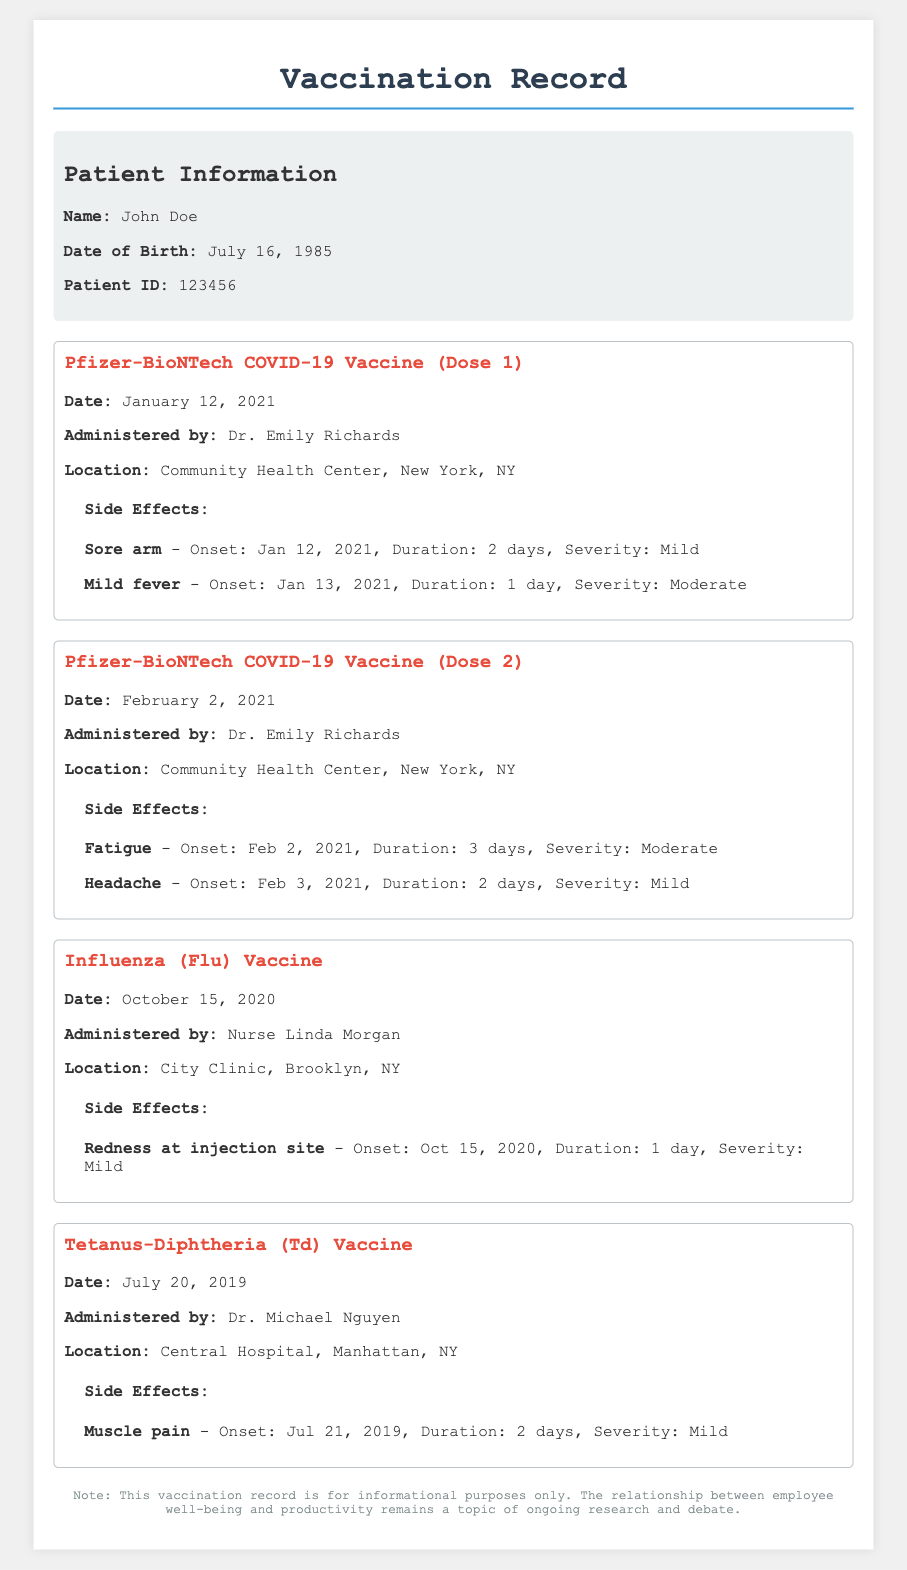What is the name of the patient? The name of the patient is listed in the patient information section of the document.
Answer: John Doe What date was the first dose of the Pfizer-BioNTech COVID-19 vaccine administered? The date of the first dose is mentioned under the vaccination record for Pfizer-BioNTech COVID-19 Vaccine (Dose 1).
Answer: January 12, 2021 Who administered the Influenza vaccine? The healthcare professional who administered the Influenza vaccine is listed in the vaccination record.
Answer: Nurse Linda Morgan What was the severity of side effects for the second dose of the Pfizer vaccine? The severity of side effects is indicated in the vaccination record for Pfizer-BioNTech COVID-19 Vaccine (Dose 2).
Answer: Moderate How many days did the fatigue last after the second dose of the Pfizer vaccine? The duration of the side effect fatigue is provided in the side effects section of the second dose of the Pfizer vaccine.
Answer: 3 days What was a side effect noted after the Tetanus-Diphtheria vaccine? A side effect is noted in the vaccination record for Tetanus-Diphtheria (Td) Vaccine.
Answer: Muscle pain When was the most recent vaccination recorded? The most recent vaccination is mentioned at the top of the vaccination records.
Answer: February 2, 2021 How long did the mild fever last after the first dose of the Pfizer vaccine? The duration of the mild fever side effect can be found in the side effects of the first dose of the Pfizer vaccine.
Answer: 1 day 